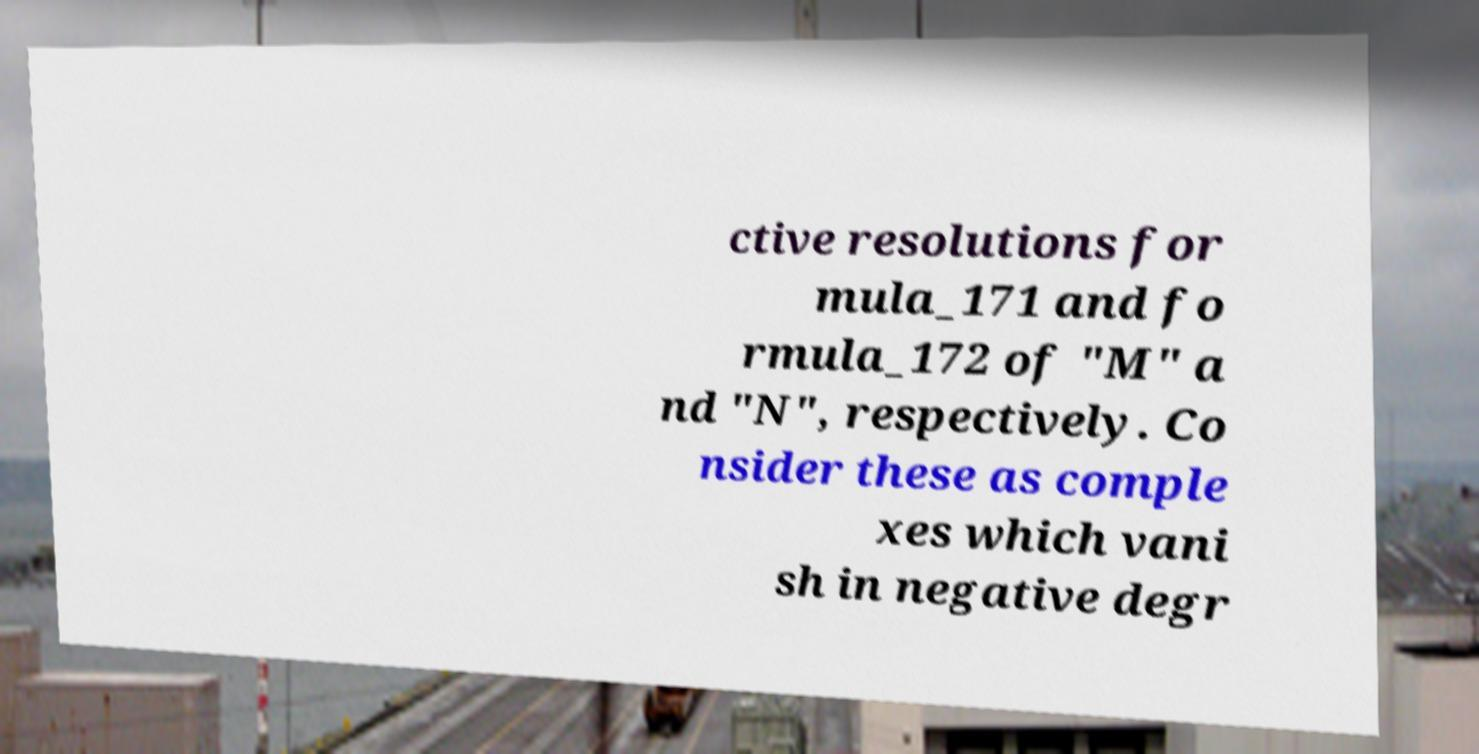Please read and relay the text visible in this image. What does it say? ctive resolutions for mula_171 and fo rmula_172 of "M" a nd "N", respectively. Co nsider these as comple xes which vani sh in negative degr 